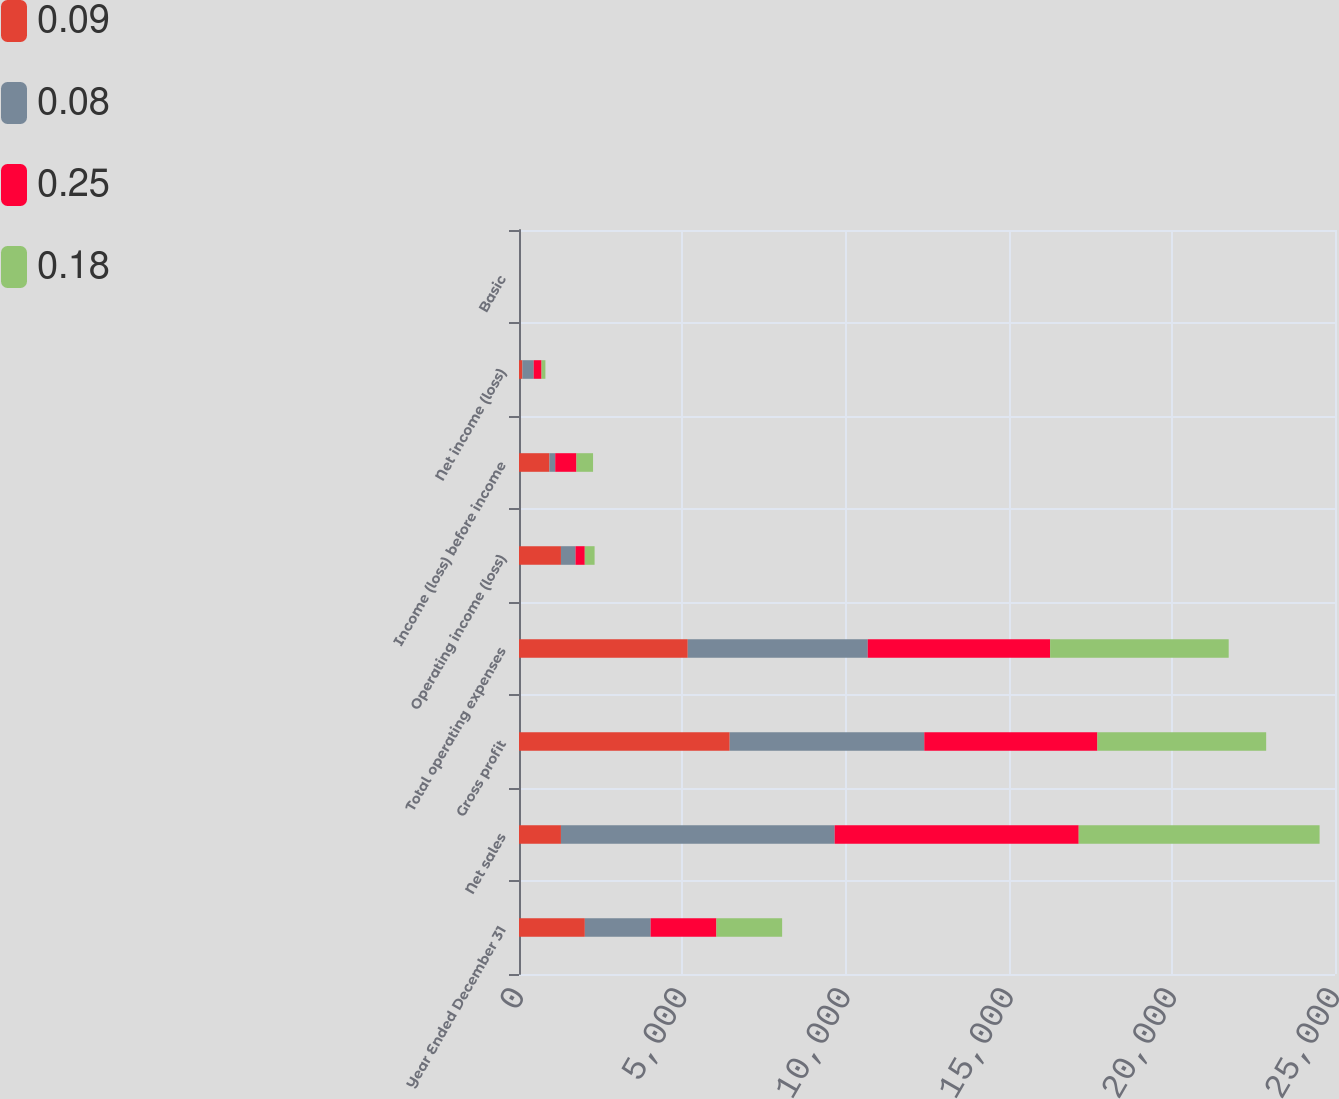Convert chart to OTSL. <chart><loc_0><loc_0><loc_500><loc_500><stacked_bar_chart><ecel><fcel>Year Ended December 31<fcel>Net sales<fcel>Gross profit<fcel>Total operating expenses<fcel>Operating income (loss)<fcel>Income (loss) before income<fcel>Net income (loss)<fcel>Basic<nl><fcel>0.09<fcel>2017<fcel>1285<fcel>6455<fcel>5170<fcel>1285<fcel>933<fcel>104<fcel>0.08<nl><fcel>0.08<fcel>2016<fcel>8386<fcel>5962<fcel>5515<fcel>447<fcel>177<fcel>347<fcel>0.26<nl><fcel>0.25<fcel>2015<fcel>7477<fcel>5304<fcel>5587<fcel>283<fcel>650<fcel>239<fcel>0.18<nl><fcel>0.18<fcel>2014<fcel>7380<fcel>5170<fcel>5471<fcel>301<fcel>509<fcel>119<fcel>0.09<nl></chart> 